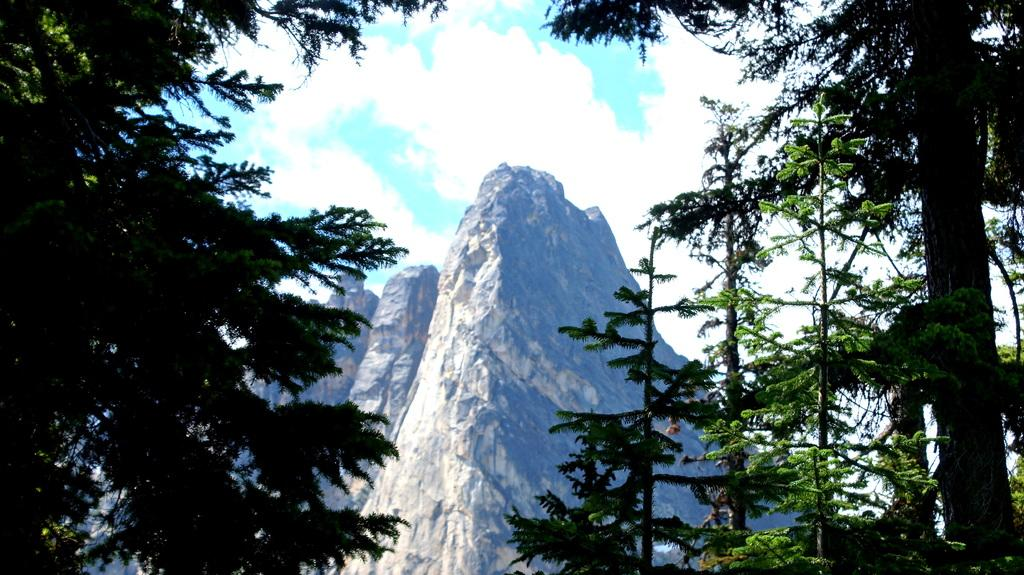What type of vegetation is visible in the front of the image? There are trees in the front of the image. What type of geographical feature is located in the center of the image? There are mountains in the center of the image. What is the condition of the sky in the image? The sky is cloudy in the image. What type of cheese can be seen melting on the trees in the image? There is no cheese present in the image; it features trees and mountains. Is there any indication of rain in the image? The image does not show any rain or rain-related elements. 